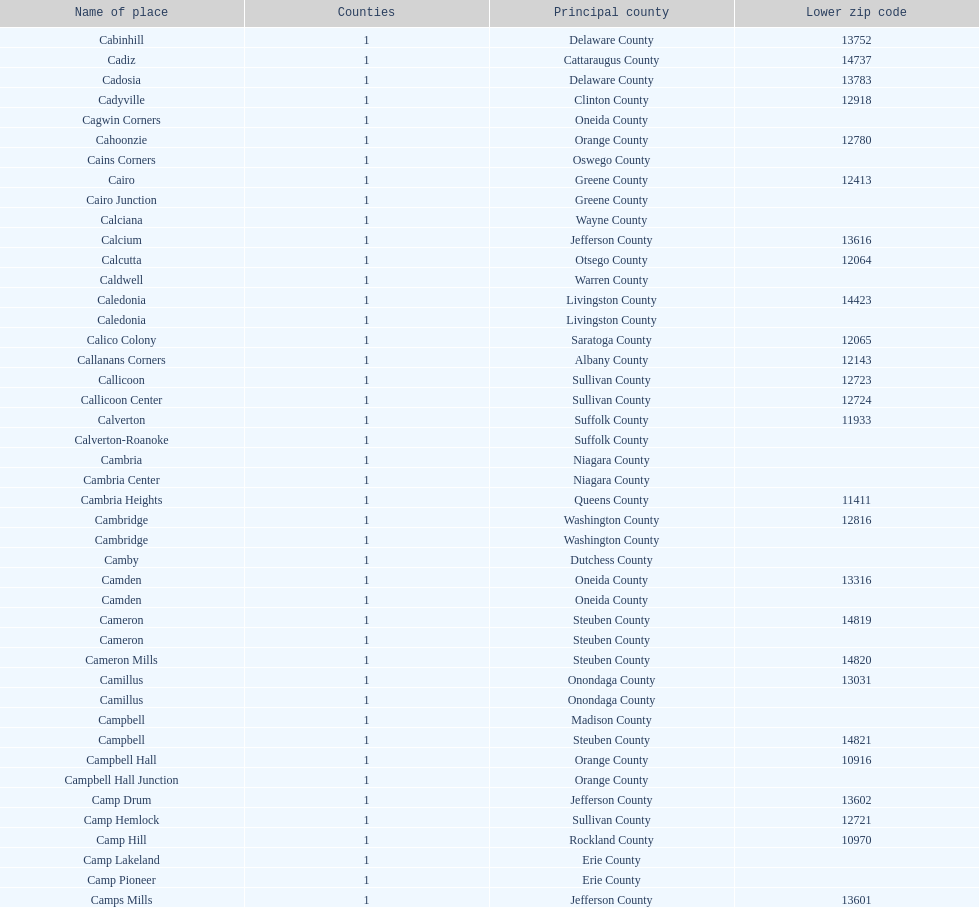Which county is cited above calciana? Cairo Junction. 